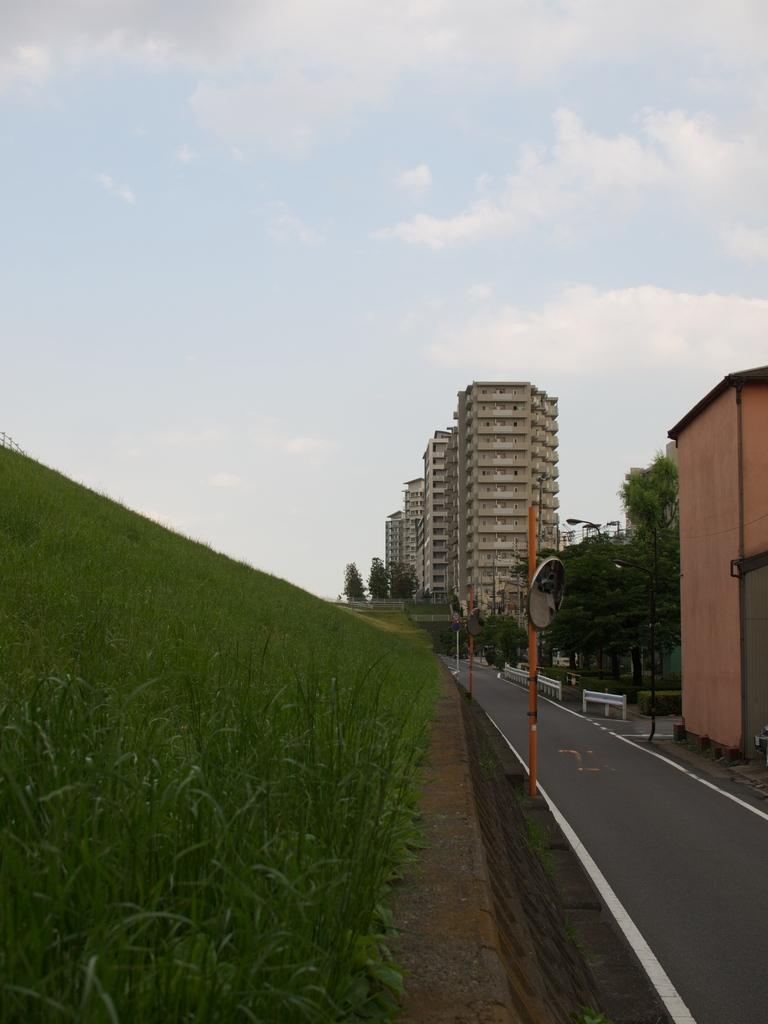What type of vegetation is present in the image? There is grass in the image. What structures can be seen in the image? There are poles and buildings in the image. What type of pathway is visible in the image? There is a road in the image. What other natural elements are present in the image? There are trees in the image. What can be seen in the background of the image? There are buildings and the sky visible in the background of the image. What brand of toothpaste is being advertised on the poles in the image? There is no toothpaste or advertisement present on the poles in the image. What type of music is being played by the band in the image? There is no band present in the image. 